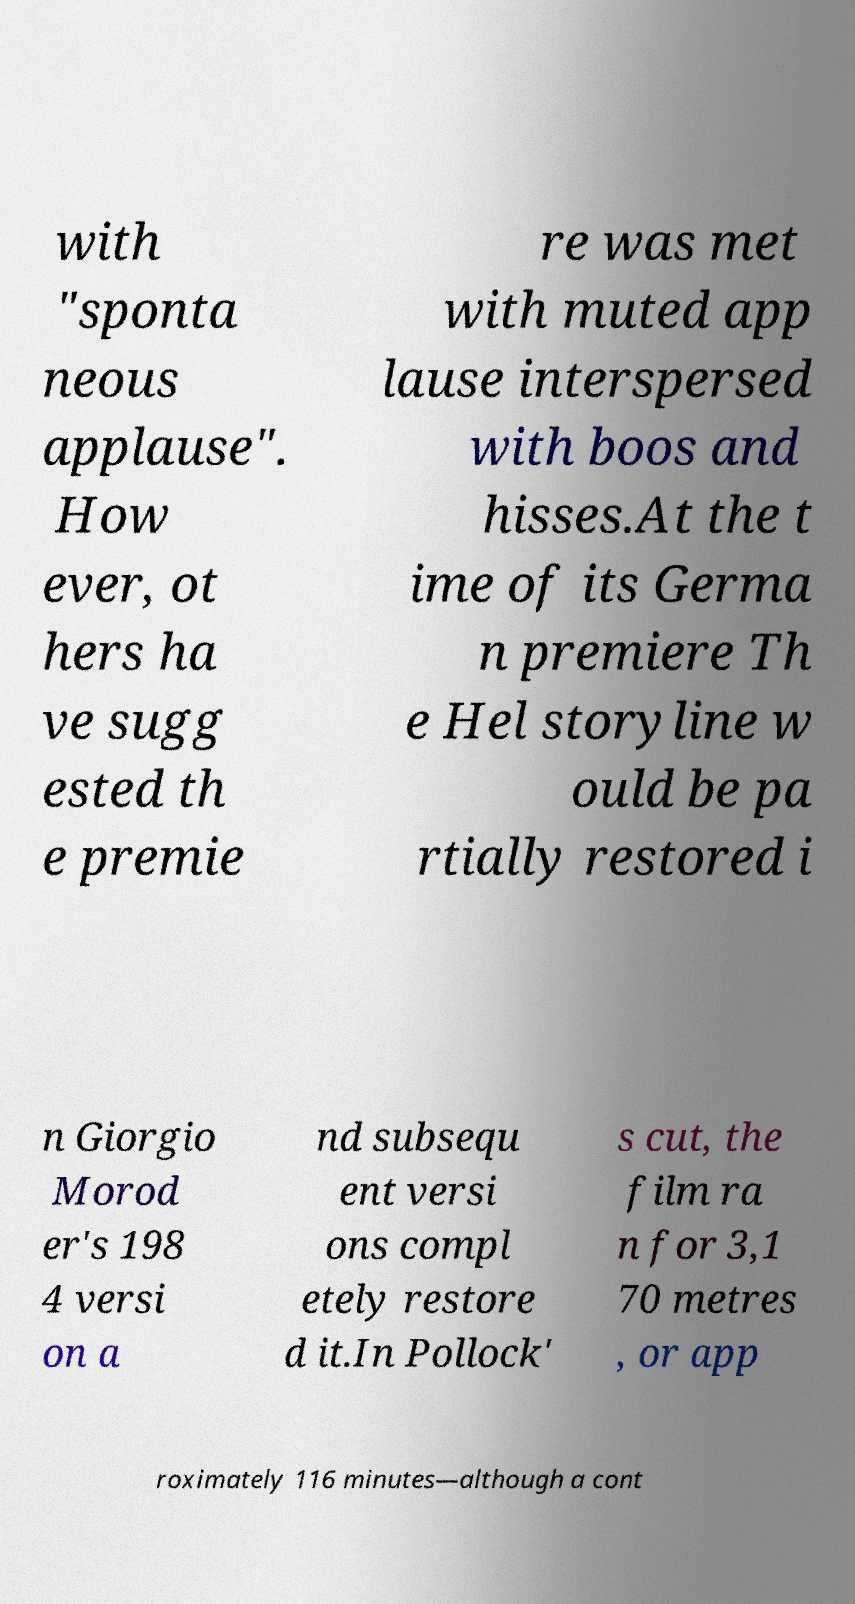Please identify and transcribe the text found in this image. with "sponta neous applause". How ever, ot hers ha ve sugg ested th e premie re was met with muted app lause interspersed with boos and hisses.At the t ime of its Germa n premiere Th e Hel storyline w ould be pa rtially restored i n Giorgio Morod er's 198 4 versi on a nd subsequ ent versi ons compl etely restore d it.In Pollock' s cut, the film ra n for 3,1 70 metres , or app roximately 116 minutes—although a cont 